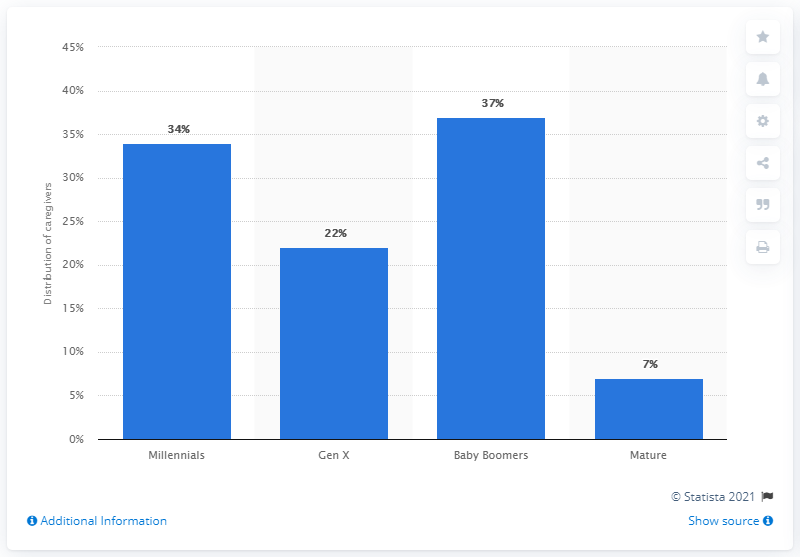Draw attention to some important aspects in this diagram. According to the survey, 34% of caregivers belong to the millennial generation. 